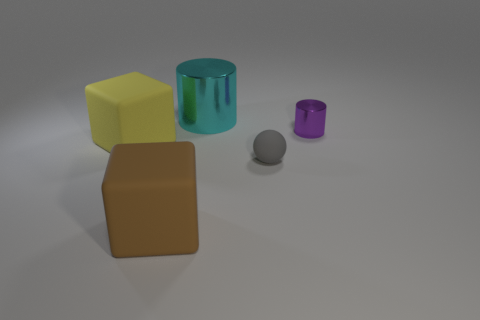There is a matte object on the right side of the cyan cylinder; is its shape the same as the large cyan shiny object?
Keep it short and to the point. No. Are there more metallic cylinders that are on the right side of the big brown cube than small gray matte objects?
Your answer should be compact. Yes. What is the object that is behind the yellow block and in front of the large metal object made of?
Your answer should be compact. Metal. Is there anything else that is the same shape as the big yellow rubber thing?
Keep it short and to the point. Yes. How many metallic cylinders are both to the right of the gray sphere and to the left of the purple metal object?
Provide a succinct answer. 0. What is the sphere made of?
Give a very brief answer. Rubber. Are there the same number of brown rubber cubes on the right side of the ball and brown blocks?
Your response must be concise. No. What number of cyan objects have the same shape as the purple object?
Keep it short and to the point. 1. Do the small purple object and the yellow thing have the same shape?
Your answer should be very brief. No. How many objects are large matte objects that are in front of the yellow object or big blue matte objects?
Your answer should be compact. 1. 